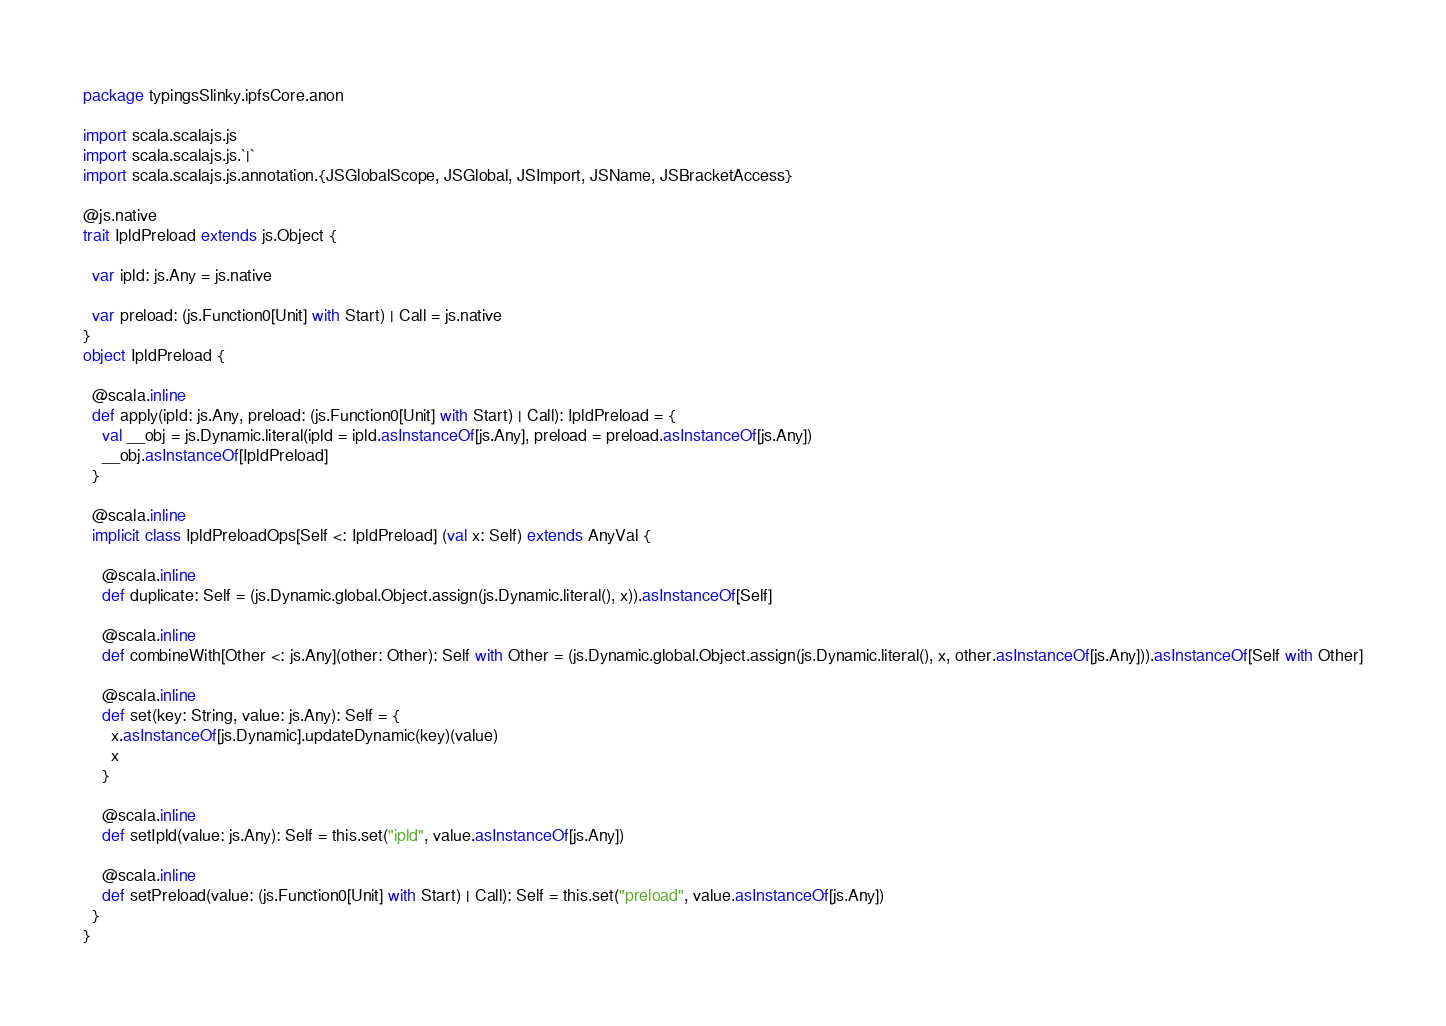Convert code to text. <code><loc_0><loc_0><loc_500><loc_500><_Scala_>package typingsSlinky.ipfsCore.anon

import scala.scalajs.js
import scala.scalajs.js.`|`
import scala.scalajs.js.annotation.{JSGlobalScope, JSGlobal, JSImport, JSName, JSBracketAccess}

@js.native
trait IpldPreload extends js.Object {
  
  var ipld: js.Any = js.native
  
  var preload: (js.Function0[Unit] with Start) | Call = js.native
}
object IpldPreload {
  
  @scala.inline
  def apply(ipld: js.Any, preload: (js.Function0[Unit] with Start) | Call): IpldPreload = {
    val __obj = js.Dynamic.literal(ipld = ipld.asInstanceOf[js.Any], preload = preload.asInstanceOf[js.Any])
    __obj.asInstanceOf[IpldPreload]
  }
  
  @scala.inline
  implicit class IpldPreloadOps[Self <: IpldPreload] (val x: Self) extends AnyVal {
    
    @scala.inline
    def duplicate: Self = (js.Dynamic.global.Object.assign(js.Dynamic.literal(), x)).asInstanceOf[Self]
    
    @scala.inline
    def combineWith[Other <: js.Any](other: Other): Self with Other = (js.Dynamic.global.Object.assign(js.Dynamic.literal(), x, other.asInstanceOf[js.Any])).asInstanceOf[Self with Other]
    
    @scala.inline
    def set(key: String, value: js.Any): Self = {
      x.asInstanceOf[js.Dynamic].updateDynamic(key)(value)
      x
    }
    
    @scala.inline
    def setIpld(value: js.Any): Self = this.set("ipld", value.asInstanceOf[js.Any])
    
    @scala.inline
    def setPreload(value: (js.Function0[Unit] with Start) | Call): Self = this.set("preload", value.asInstanceOf[js.Any])
  }
}
</code> 